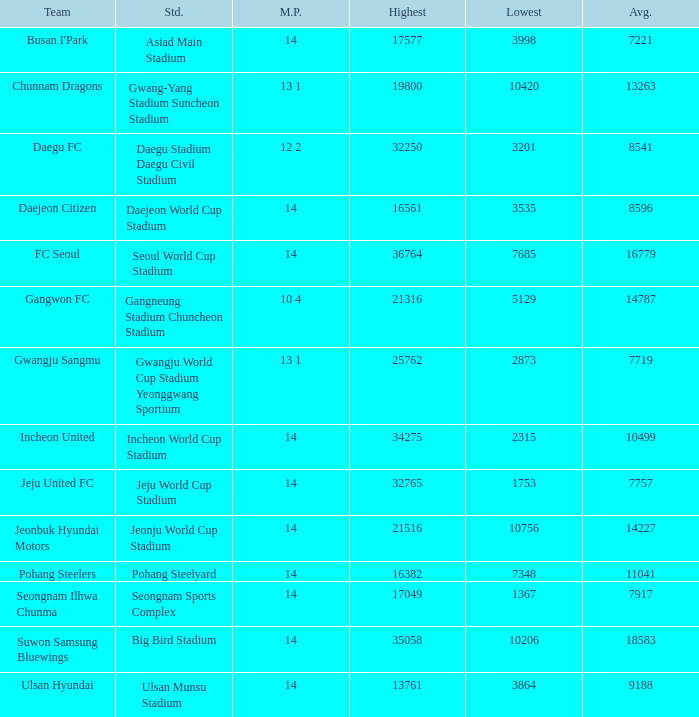Which squad has 7757 as the mean value? Jeju United FC. 